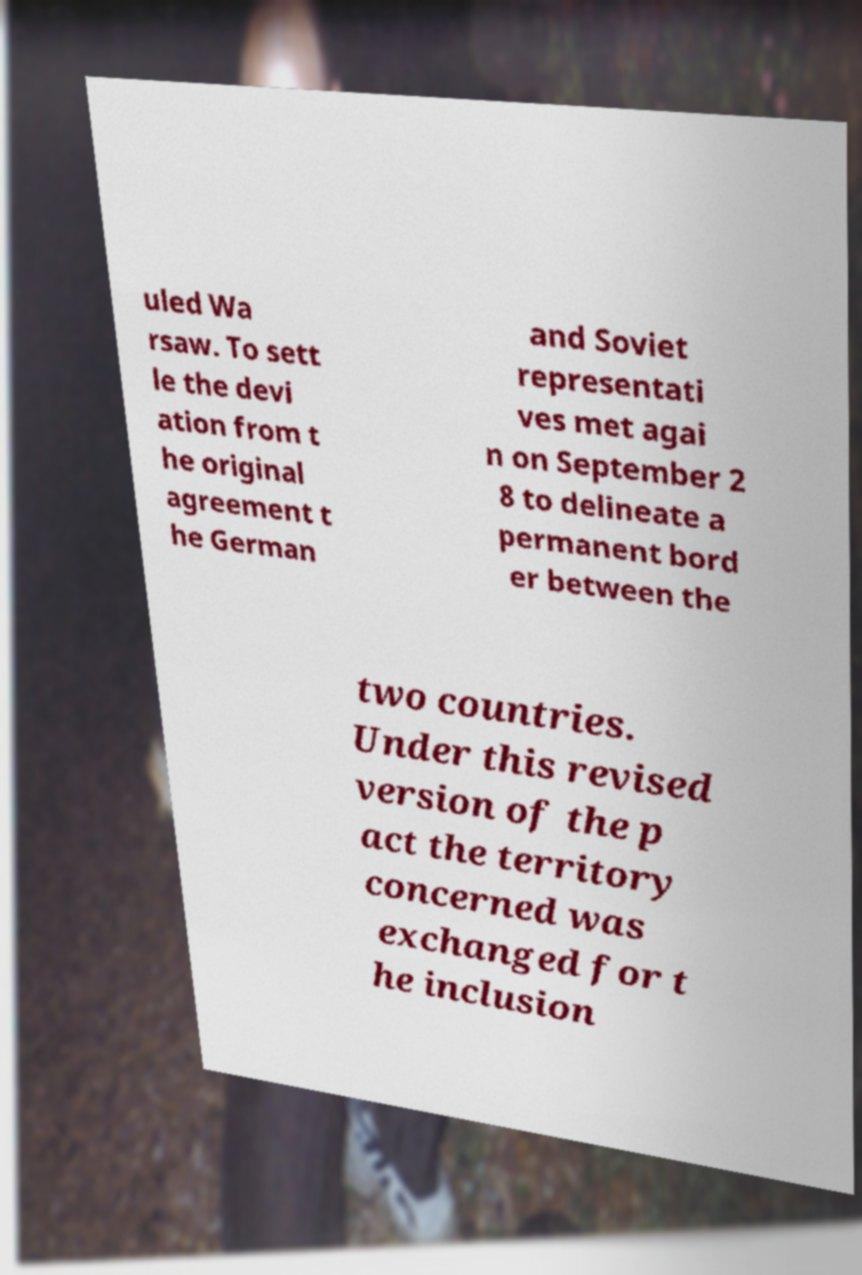What messages or text are displayed in this image? I need them in a readable, typed format. uled Wa rsaw. To sett le the devi ation from t he original agreement t he German and Soviet representati ves met agai n on September 2 8 to delineate a permanent bord er between the two countries. Under this revised version of the p act the territory concerned was exchanged for t he inclusion 